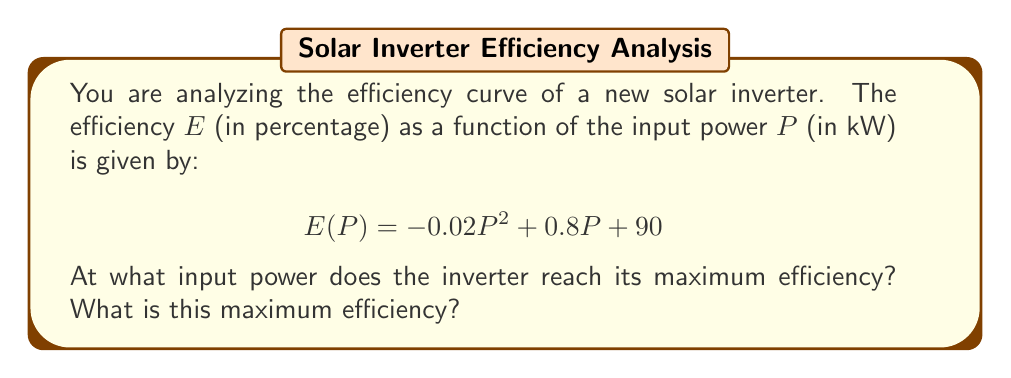Give your solution to this math problem. To find the maximum efficiency, we need to determine where the derivative of the efficiency function equals zero. This will give us the critical point, which in this case will be the maximum.

Step 1: Calculate the derivative of $E(P)$
$$\frac{dE}{dP} = -0.04P + 0.8$$

Step 2: Set the derivative equal to zero and solve for P
$$-0.04P + 0.8 = 0$$
$$-0.04P = -0.8$$
$$P = 20$$

Step 3: Verify this is a maximum by checking the second derivative
$$\frac{d^2E}{dP^2} = -0.04$$
Since the second derivative is negative, this confirms we have a maximum.

Step 4: Calculate the maximum efficiency by plugging $P = 20$ into the original function
$$E(20) = -0.02(20)^2 + 0.8(20) + 90$$
$$= -8 + 16 + 90$$
$$= 98$$

Therefore, the inverter reaches its maximum efficiency at an input power of 20 kW, and the maximum efficiency is 98%.
Answer: 20 kW; 98% 